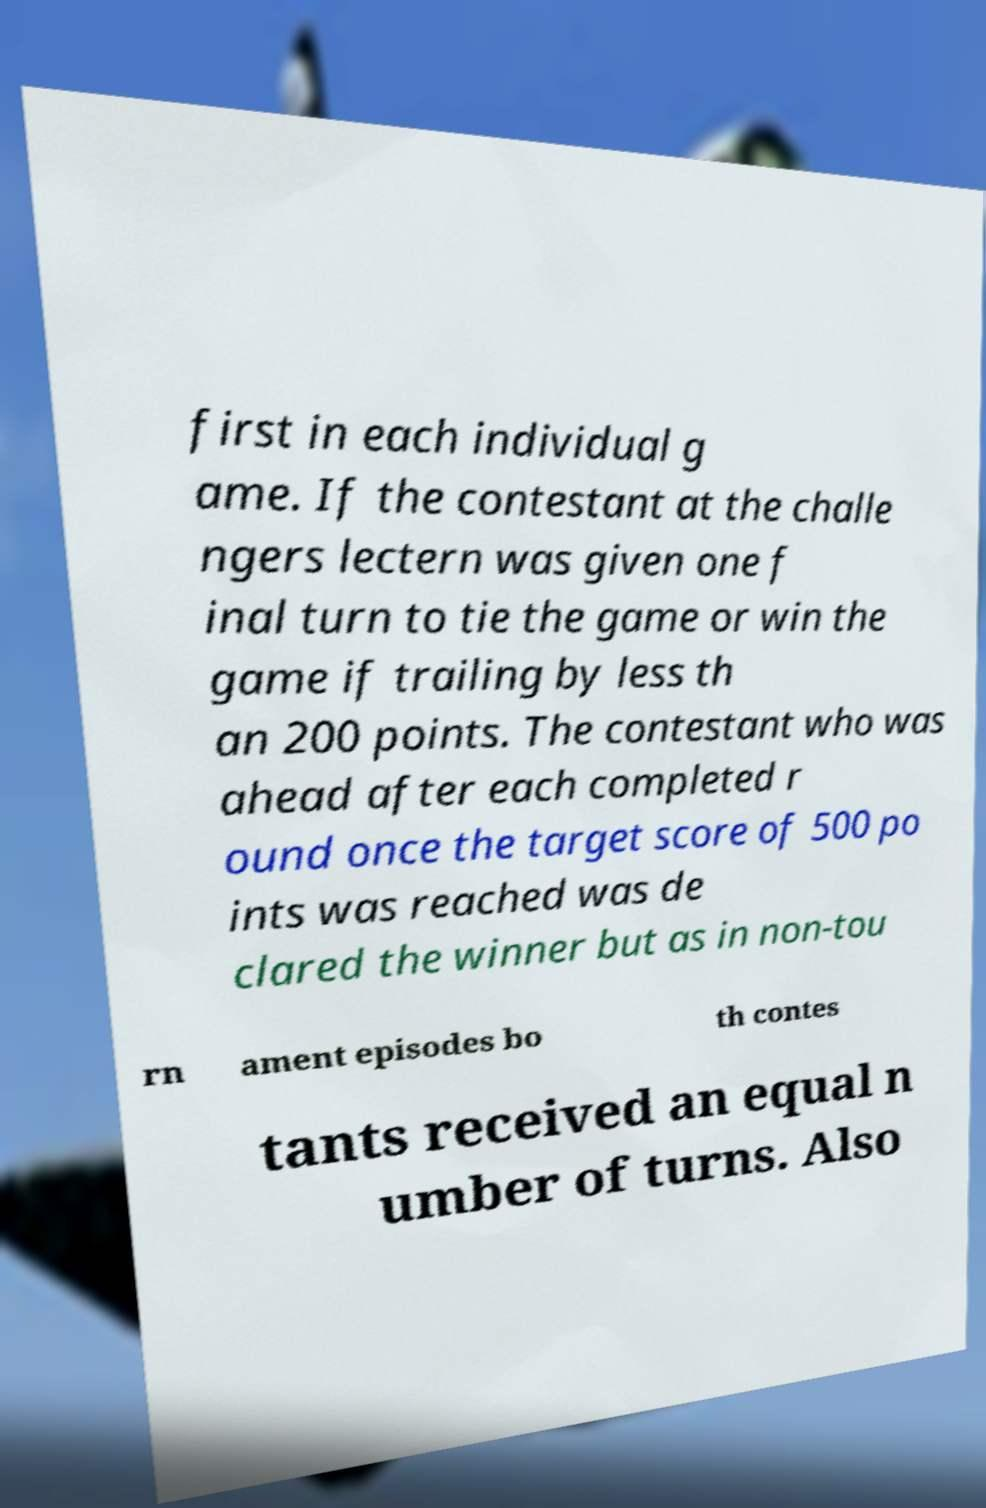Please identify and transcribe the text found in this image. first in each individual g ame. If the contestant at the challe ngers lectern was given one f inal turn to tie the game or win the game if trailing by less th an 200 points. The contestant who was ahead after each completed r ound once the target score of 500 po ints was reached was de clared the winner but as in non-tou rn ament episodes bo th contes tants received an equal n umber of turns. Also 